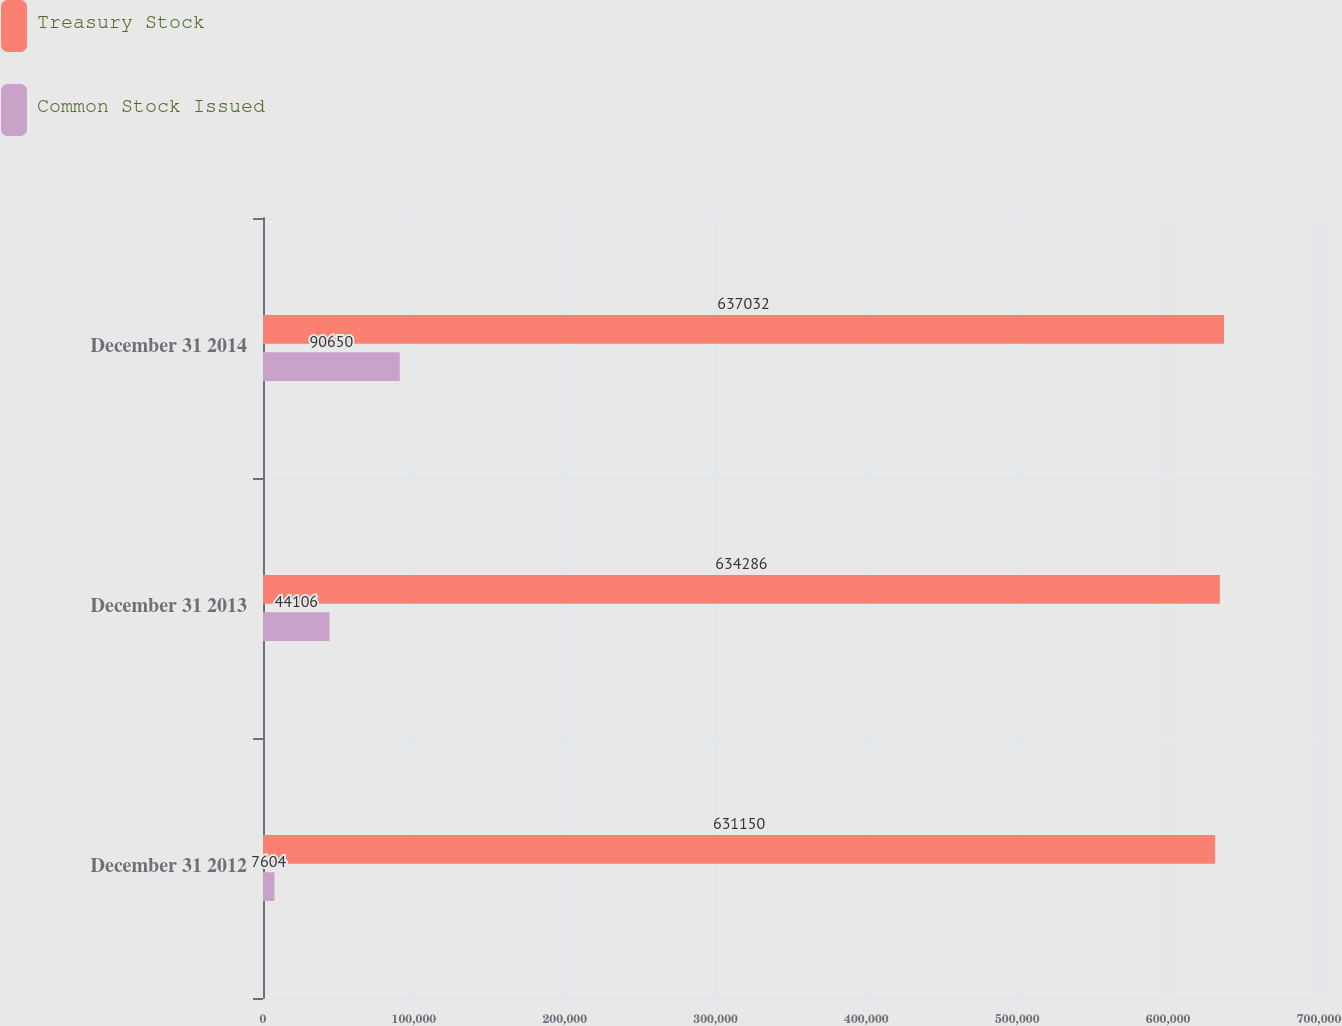Convert chart. <chart><loc_0><loc_0><loc_500><loc_500><stacked_bar_chart><ecel><fcel>December 31 2012<fcel>December 31 2013<fcel>December 31 2014<nl><fcel>Treasury Stock<fcel>631150<fcel>634286<fcel>637032<nl><fcel>Common Stock Issued<fcel>7604<fcel>44106<fcel>90650<nl></chart> 